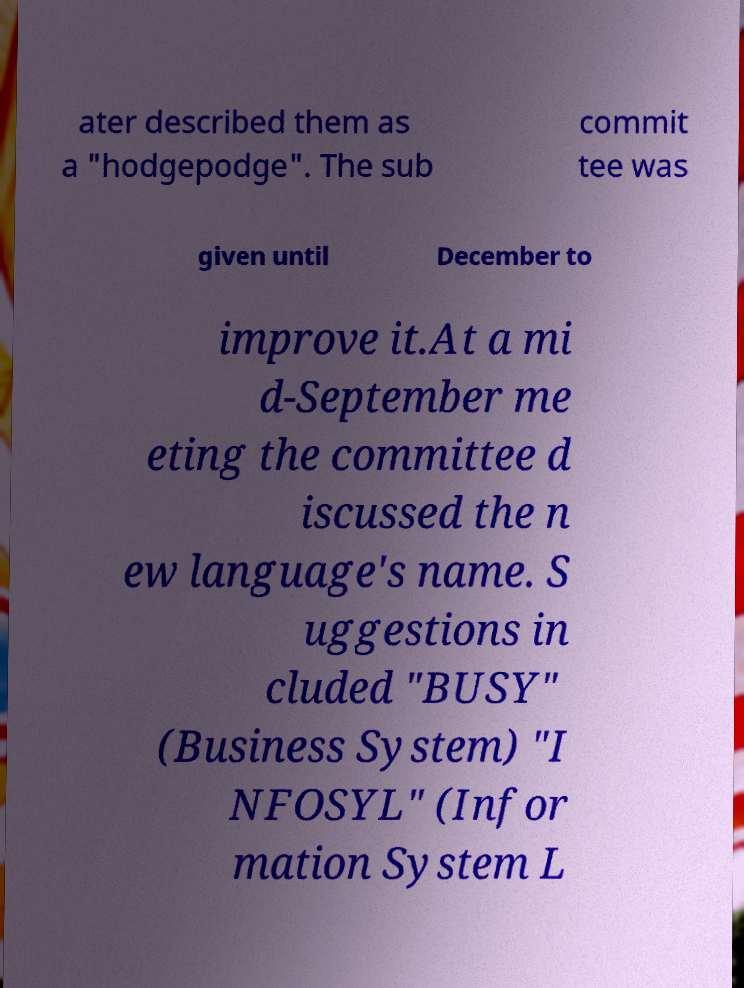Can you accurately transcribe the text from the provided image for me? ater described them as a "hodgepodge". The sub commit tee was given until December to improve it.At a mi d-September me eting the committee d iscussed the n ew language's name. S uggestions in cluded "BUSY" (Business System) "I NFOSYL" (Infor mation System L 